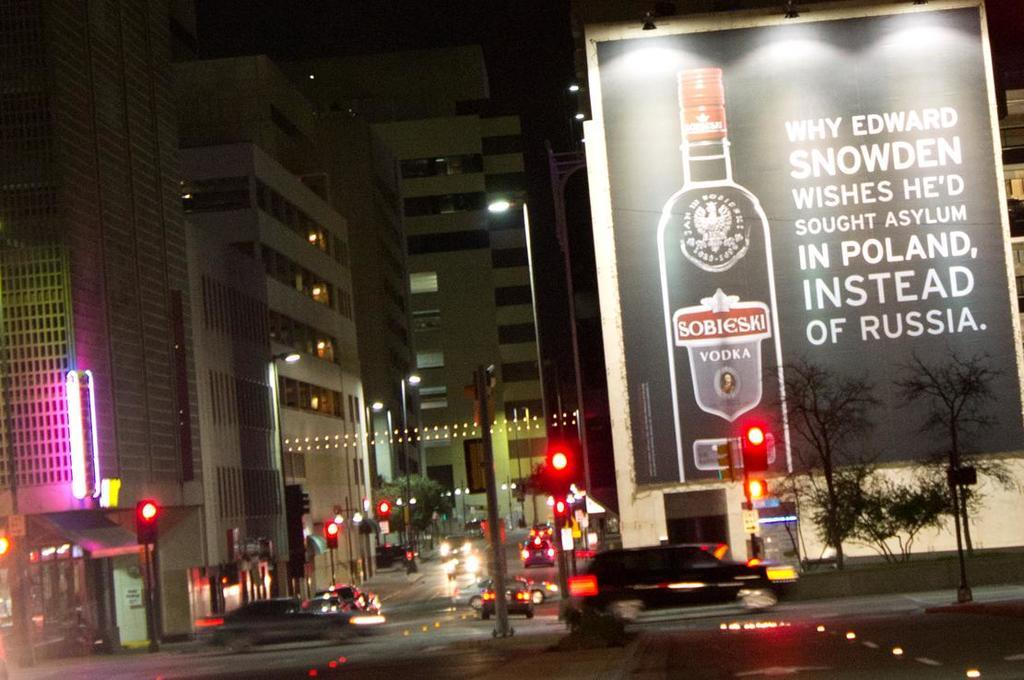What type of vehicles can be seen in the image? There are cars in the image. What other objects are visible in the image? There are lights, poles, buildings, trees, and a poster with text. Where are the additional lights and trees located in the image? The additional lights and trees are on the right side of the image. What is the poster on the right side of the image about? The poster has text associated with it, but the specific content is not mentioned in the facts. How many cars are visible in the image? There are at least two cars visible in the image, one on the left side and another on the right side. What type of snake can be seen slithering across the poster in the image? There is no snake present in the image; the poster has text associated with it, but no snake is mentioned or visible. 